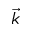Convert formula to latex. <formula><loc_0><loc_0><loc_500><loc_500>\vec { k }</formula> 